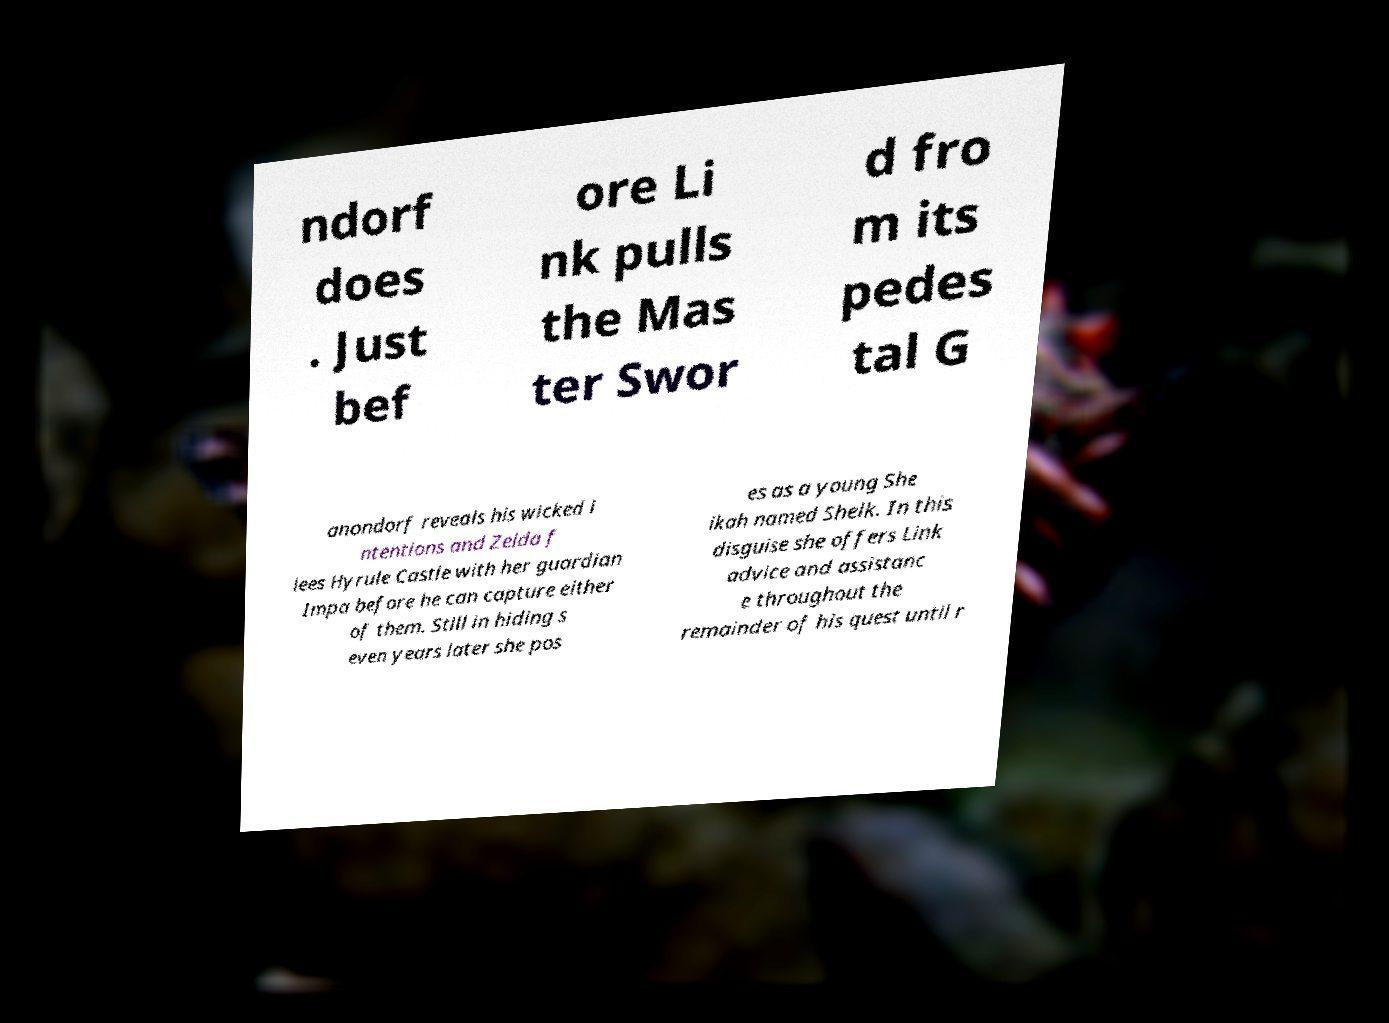Could you assist in decoding the text presented in this image and type it out clearly? ndorf does . Just bef ore Li nk pulls the Mas ter Swor d fro m its pedes tal G anondorf reveals his wicked i ntentions and Zelda f lees Hyrule Castle with her guardian Impa before he can capture either of them. Still in hiding s even years later she pos es as a young She ikah named Sheik. In this disguise she offers Link advice and assistanc e throughout the remainder of his quest until r 